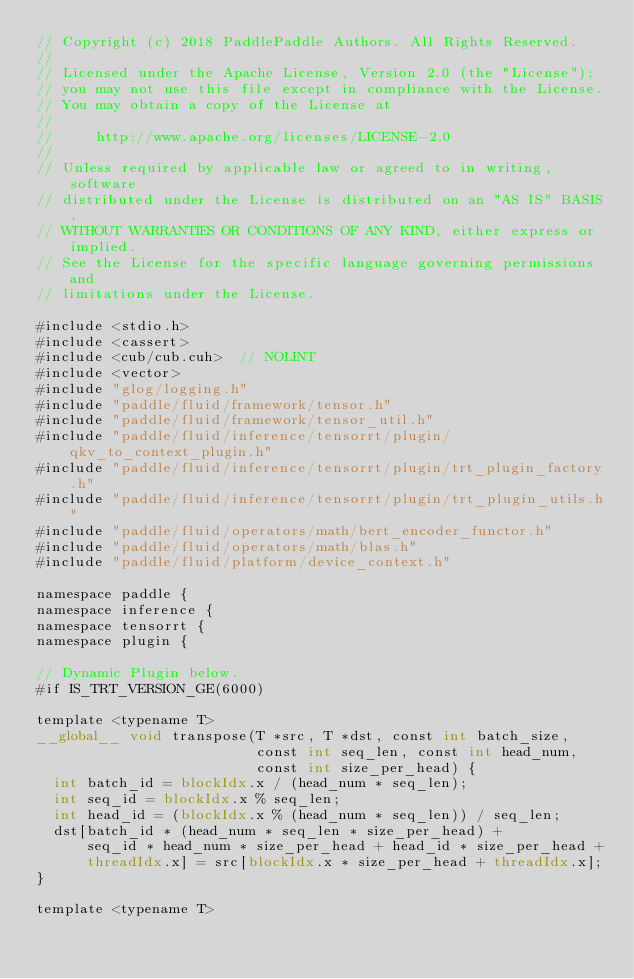<code> <loc_0><loc_0><loc_500><loc_500><_Cuda_>// Copyright (c) 2018 PaddlePaddle Authors. All Rights Reserved.
//
// Licensed under the Apache License, Version 2.0 (the "License");
// you may not use this file except in compliance with the License.
// You may obtain a copy of the License at
//
//     http://www.apache.org/licenses/LICENSE-2.0
//
// Unless required by applicable law or agreed to in writing, software
// distributed under the License is distributed on an "AS IS" BASIS,
// WITHOUT WARRANTIES OR CONDITIONS OF ANY KIND, either express or implied.
// See the License for the specific language governing permissions and
// limitations under the License.

#include <stdio.h>
#include <cassert>
#include <cub/cub.cuh>  // NOLINT
#include <vector>
#include "glog/logging.h"
#include "paddle/fluid/framework/tensor.h"
#include "paddle/fluid/framework/tensor_util.h"
#include "paddle/fluid/inference/tensorrt/plugin/qkv_to_context_plugin.h"
#include "paddle/fluid/inference/tensorrt/plugin/trt_plugin_factory.h"
#include "paddle/fluid/inference/tensorrt/plugin/trt_plugin_utils.h"
#include "paddle/fluid/operators/math/bert_encoder_functor.h"
#include "paddle/fluid/operators/math/blas.h"
#include "paddle/fluid/platform/device_context.h"

namespace paddle {
namespace inference {
namespace tensorrt {
namespace plugin {

// Dynamic Plugin below.
#if IS_TRT_VERSION_GE(6000)

template <typename T>
__global__ void transpose(T *src, T *dst, const int batch_size,
                          const int seq_len, const int head_num,
                          const int size_per_head) {
  int batch_id = blockIdx.x / (head_num * seq_len);
  int seq_id = blockIdx.x % seq_len;
  int head_id = (blockIdx.x % (head_num * seq_len)) / seq_len;
  dst[batch_id * (head_num * seq_len * size_per_head) +
      seq_id * head_num * size_per_head + head_id * size_per_head +
      threadIdx.x] = src[blockIdx.x * size_per_head + threadIdx.x];
}

template <typename T></code> 